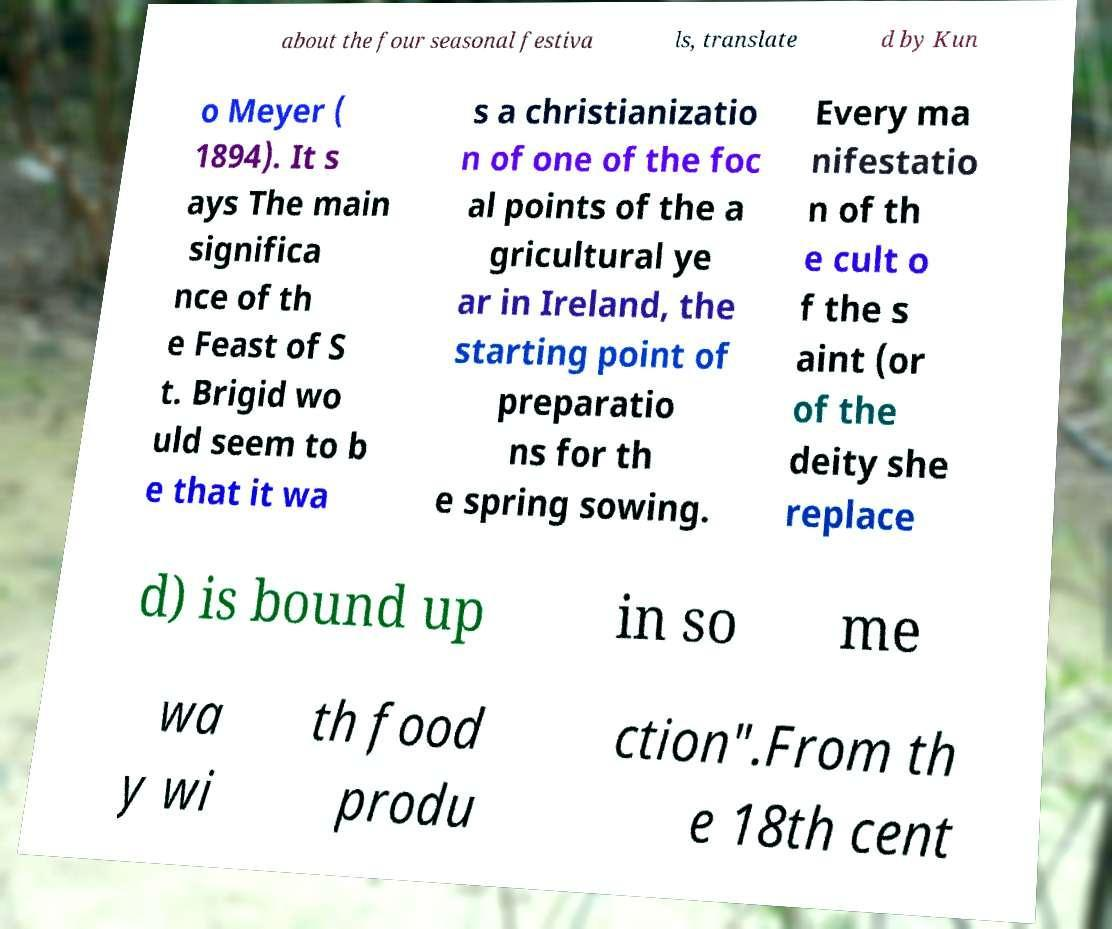What messages or text are displayed in this image? I need them in a readable, typed format. about the four seasonal festiva ls, translate d by Kun o Meyer ( 1894). It s ays The main significa nce of th e Feast of S t. Brigid wo uld seem to b e that it wa s a christianizatio n of one of the foc al points of the a gricultural ye ar in Ireland, the starting point of preparatio ns for th e spring sowing. Every ma nifestatio n of th e cult o f the s aint (or of the deity she replace d) is bound up in so me wa y wi th food produ ction".From th e 18th cent 